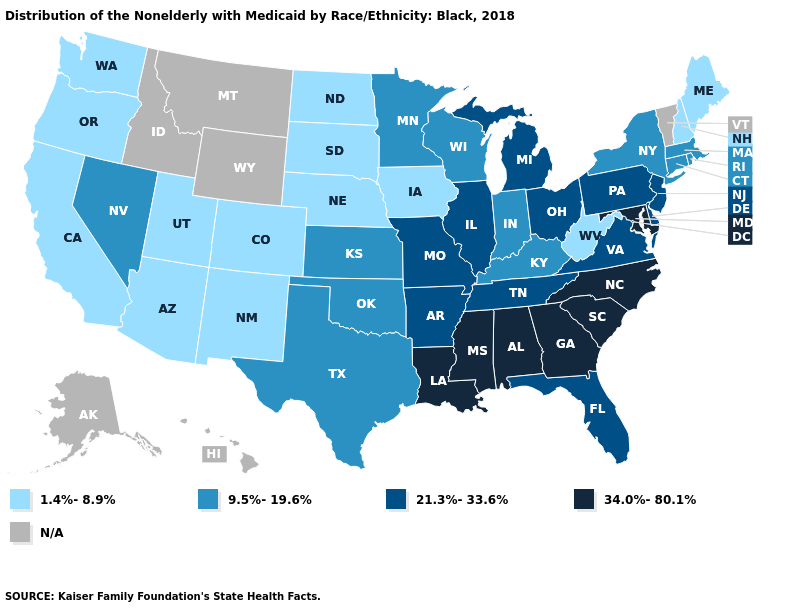What is the value of Ohio?
Short answer required. 21.3%-33.6%. What is the value of Missouri?
Be succinct. 21.3%-33.6%. Which states have the highest value in the USA?
Quick response, please. Alabama, Georgia, Louisiana, Maryland, Mississippi, North Carolina, South Carolina. What is the value of South Dakota?
Short answer required. 1.4%-8.9%. What is the lowest value in the South?
Short answer required. 1.4%-8.9%. Name the states that have a value in the range 9.5%-19.6%?
Keep it brief. Connecticut, Indiana, Kansas, Kentucky, Massachusetts, Minnesota, Nevada, New York, Oklahoma, Rhode Island, Texas, Wisconsin. What is the highest value in states that border Nevada?
Concise answer only. 1.4%-8.9%. Is the legend a continuous bar?
Quick response, please. No. Does Oregon have the lowest value in the USA?
Concise answer only. Yes. Name the states that have a value in the range 1.4%-8.9%?
Be succinct. Arizona, California, Colorado, Iowa, Maine, Nebraska, New Hampshire, New Mexico, North Dakota, Oregon, South Dakota, Utah, Washington, West Virginia. Name the states that have a value in the range 1.4%-8.9%?
Keep it brief. Arizona, California, Colorado, Iowa, Maine, Nebraska, New Hampshire, New Mexico, North Dakota, Oregon, South Dakota, Utah, Washington, West Virginia. Which states have the lowest value in the South?
Answer briefly. West Virginia. Name the states that have a value in the range 21.3%-33.6%?
Write a very short answer. Arkansas, Delaware, Florida, Illinois, Michigan, Missouri, New Jersey, Ohio, Pennsylvania, Tennessee, Virginia. Does West Virginia have the lowest value in the USA?
Quick response, please. Yes. 